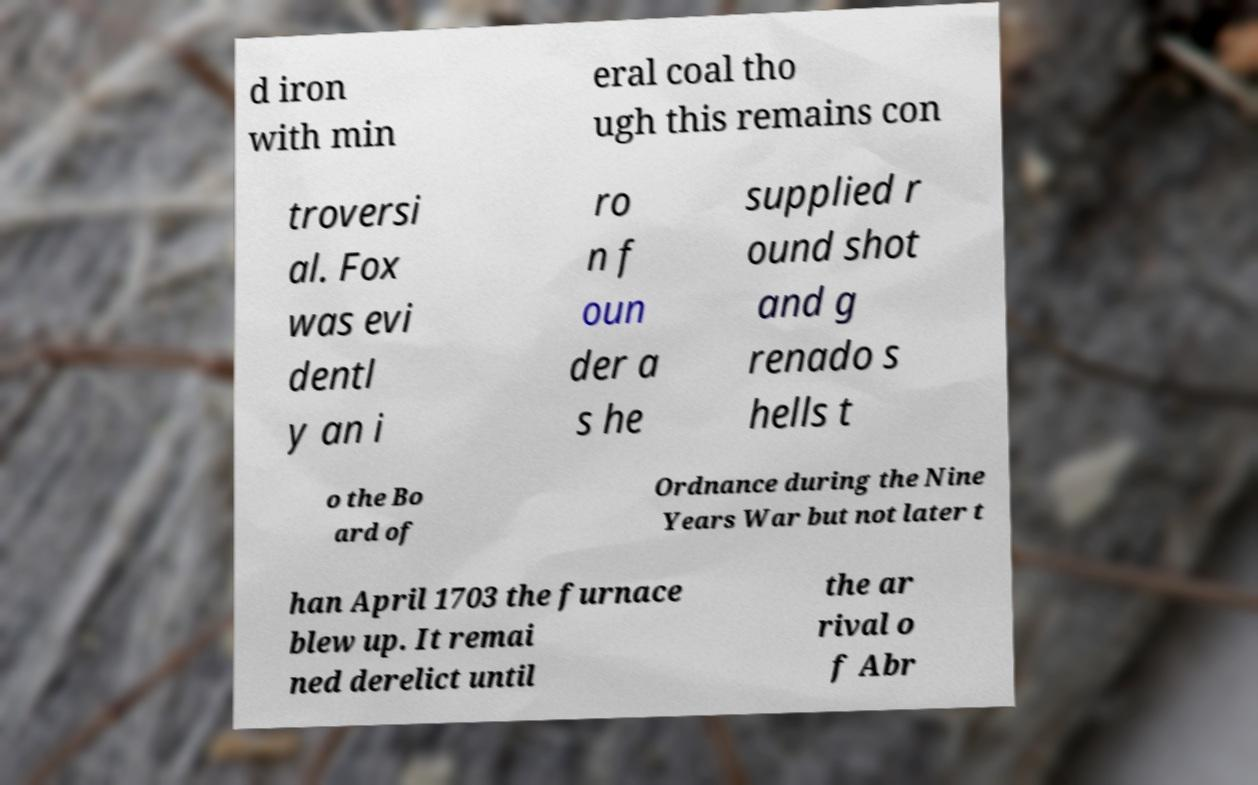Could you extract and type out the text from this image? d iron with min eral coal tho ugh this remains con troversi al. Fox was evi dentl y an i ro n f oun der a s he supplied r ound shot and g renado s hells t o the Bo ard of Ordnance during the Nine Years War but not later t han April 1703 the furnace blew up. It remai ned derelict until the ar rival o f Abr 